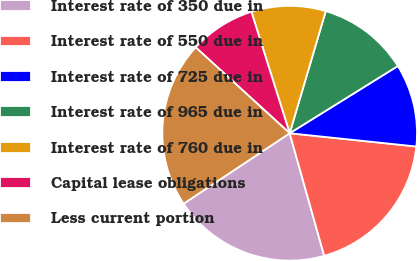Convert chart to OTSL. <chart><loc_0><loc_0><loc_500><loc_500><pie_chart><fcel>Interest rate of 350 due in<fcel>Interest rate of 550 due in<fcel>Interest rate of 725 due in<fcel>Interest rate of 965 due in<fcel>Interest rate of 760 due in<fcel>Capital lease obligations<fcel>Less current portion<nl><fcel>20.04%<fcel>18.97%<fcel>10.51%<fcel>11.58%<fcel>9.43%<fcel>8.36%<fcel>21.11%<nl></chart> 